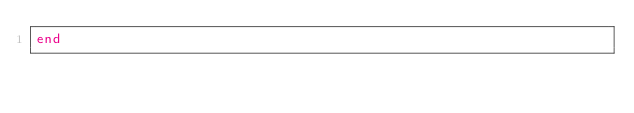Convert code to text. <code><loc_0><loc_0><loc_500><loc_500><_Ruby_>end
</code> 